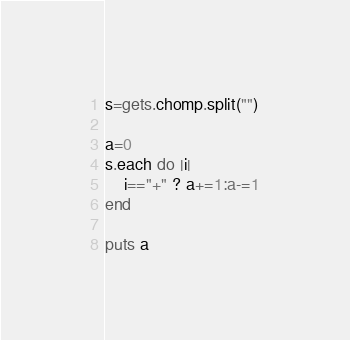Convert code to text. <code><loc_0><loc_0><loc_500><loc_500><_Ruby_>s=gets.chomp.split("")

a=0
s.each do |i|
    i=="+" ? a+=1:a-=1
end

puts a</code> 